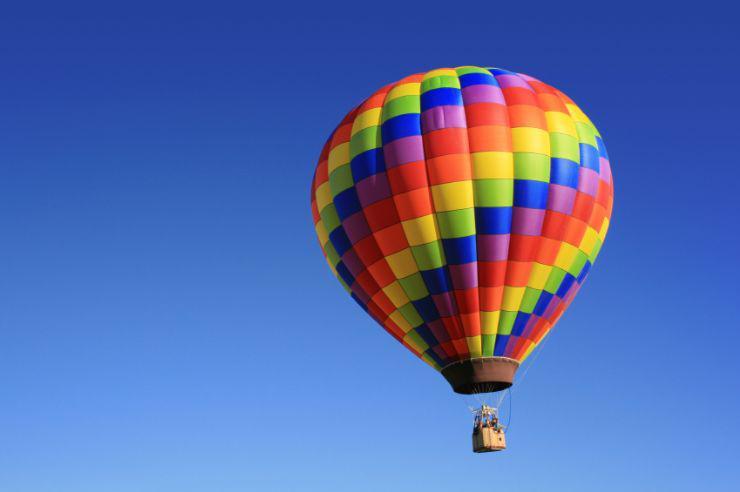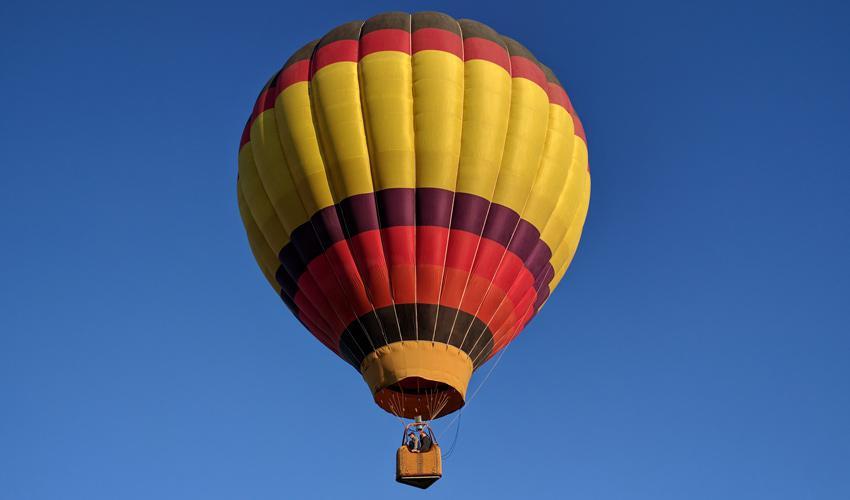The first image is the image on the left, the second image is the image on the right. Analyze the images presented: Is the assertion "There are more than 5 balloons in one of the images." valid? Answer yes or no. No. 